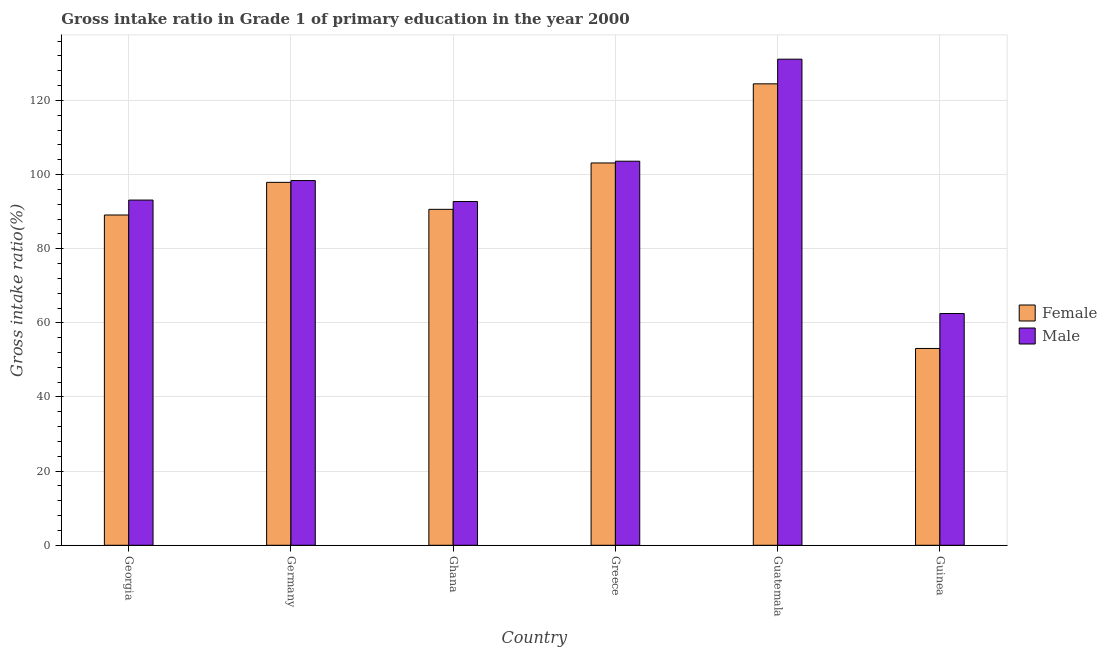How many different coloured bars are there?
Keep it short and to the point. 2. How many groups of bars are there?
Your answer should be very brief. 6. Are the number of bars on each tick of the X-axis equal?
Offer a terse response. Yes. How many bars are there on the 6th tick from the right?
Your answer should be compact. 2. What is the label of the 6th group of bars from the left?
Make the answer very short. Guinea. What is the gross intake ratio(male) in Greece?
Provide a succinct answer. 103.6. Across all countries, what is the maximum gross intake ratio(male)?
Offer a terse response. 131.12. Across all countries, what is the minimum gross intake ratio(male)?
Provide a succinct answer. 62.51. In which country was the gross intake ratio(male) maximum?
Provide a succinct answer. Guatemala. In which country was the gross intake ratio(male) minimum?
Give a very brief answer. Guinea. What is the total gross intake ratio(male) in the graph?
Offer a very short reply. 581.45. What is the difference between the gross intake ratio(female) in Georgia and that in Germany?
Your answer should be compact. -8.81. What is the difference between the gross intake ratio(female) in Ghana and the gross intake ratio(male) in Guatemala?
Offer a terse response. -40.5. What is the average gross intake ratio(female) per country?
Your answer should be compact. 93.05. What is the difference between the gross intake ratio(male) and gross intake ratio(female) in Guinea?
Ensure brevity in your answer.  9.42. What is the ratio of the gross intake ratio(male) in Guatemala to that in Guinea?
Provide a short and direct response. 2.1. Is the gross intake ratio(male) in Georgia less than that in Germany?
Give a very brief answer. Yes. What is the difference between the highest and the second highest gross intake ratio(female)?
Your answer should be compact. 21.34. What is the difference between the highest and the lowest gross intake ratio(male)?
Provide a succinct answer. 68.61. Are all the bars in the graph horizontal?
Offer a terse response. No. How many countries are there in the graph?
Ensure brevity in your answer.  6. Does the graph contain grids?
Ensure brevity in your answer.  Yes. How many legend labels are there?
Keep it short and to the point. 2. How are the legend labels stacked?
Make the answer very short. Vertical. What is the title of the graph?
Provide a short and direct response. Gross intake ratio in Grade 1 of primary education in the year 2000. What is the label or title of the X-axis?
Your answer should be very brief. Country. What is the label or title of the Y-axis?
Offer a very short reply. Gross intake ratio(%). What is the Gross intake ratio(%) in Female in Georgia?
Your response must be concise. 89.09. What is the Gross intake ratio(%) of Male in Georgia?
Give a very brief answer. 93.12. What is the Gross intake ratio(%) of Female in Germany?
Provide a succinct answer. 97.9. What is the Gross intake ratio(%) in Male in Germany?
Ensure brevity in your answer.  98.38. What is the Gross intake ratio(%) in Female in Ghana?
Offer a terse response. 90.62. What is the Gross intake ratio(%) of Male in Ghana?
Keep it short and to the point. 92.73. What is the Gross intake ratio(%) in Female in Greece?
Give a very brief answer. 103.13. What is the Gross intake ratio(%) in Male in Greece?
Your response must be concise. 103.6. What is the Gross intake ratio(%) in Female in Guatemala?
Offer a very short reply. 124.47. What is the Gross intake ratio(%) in Male in Guatemala?
Give a very brief answer. 131.12. What is the Gross intake ratio(%) in Female in Guinea?
Provide a short and direct response. 53.09. What is the Gross intake ratio(%) in Male in Guinea?
Offer a very short reply. 62.51. Across all countries, what is the maximum Gross intake ratio(%) in Female?
Offer a terse response. 124.47. Across all countries, what is the maximum Gross intake ratio(%) in Male?
Your response must be concise. 131.12. Across all countries, what is the minimum Gross intake ratio(%) in Female?
Make the answer very short. 53.09. Across all countries, what is the minimum Gross intake ratio(%) of Male?
Provide a succinct answer. 62.51. What is the total Gross intake ratio(%) of Female in the graph?
Offer a terse response. 558.29. What is the total Gross intake ratio(%) in Male in the graph?
Give a very brief answer. 581.45. What is the difference between the Gross intake ratio(%) of Female in Georgia and that in Germany?
Provide a succinct answer. -8.81. What is the difference between the Gross intake ratio(%) in Male in Georgia and that in Germany?
Offer a terse response. -5.26. What is the difference between the Gross intake ratio(%) of Female in Georgia and that in Ghana?
Your response must be concise. -1.53. What is the difference between the Gross intake ratio(%) of Male in Georgia and that in Ghana?
Ensure brevity in your answer.  0.39. What is the difference between the Gross intake ratio(%) in Female in Georgia and that in Greece?
Your response must be concise. -14.04. What is the difference between the Gross intake ratio(%) of Male in Georgia and that in Greece?
Provide a succinct answer. -10.48. What is the difference between the Gross intake ratio(%) of Female in Georgia and that in Guatemala?
Provide a succinct answer. -35.38. What is the difference between the Gross intake ratio(%) of Male in Georgia and that in Guatemala?
Provide a succinct answer. -38.01. What is the difference between the Gross intake ratio(%) of Female in Georgia and that in Guinea?
Provide a short and direct response. 36. What is the difference between the Gross intake ratio(%) in Male in Georgia and that in Guinea?
Offer a very short reply. 30.6. What is the difference between the Gross intake ratio(%) in Female in Germany and that in Ghana?
Offer a terse response. 7.28. What is the difference between the Gross intake ratio(%) of Male in Germany and that in Ghana?
Make the answer very short. 5.65. What is the difference between the Gross intake ratio(%) of Female in Germany and that in Greece?
Ensure brevity in your answer.  -5.23. What is the difference between the Gross intake ratio(%) in Male in Germany and that in Greece?
Offer a terse response. -5.22. What is the difference between the Gross intake ratio(%) in Female in Germany and that in Guatemala?
Provide a short and direct response. -26.57. What is the difference between the Gross intake ratio(%) in Male in Germany and that in Guatemala?
Offer a very short reply. -32.74. What is the difference between the Gross intake ratio(%) in Female in Germany and that in Guinea?
Keep it short and to the point. 44.81. What is the difference between the Gross intake ratio(%) in Male in Germany and that in Guinea?
Provide a short and direct response. 35.87. What is the difference between the Gross intake ratio(%) in Female in Ghana and that in Greece?
Give a very brief answer. -12.51. What is the difference between the Gross intake ratio(%) of Male in Ghana and that in Greece?
Provide a short and direct response. -10.87. What is the difference between the Gross intake ratio(%) of Female in Ghana and that in Guatemala?
Give a very brief answer. -33.85. What is the difference between the Gross intake ratio(%) of Male in Ghana and that in Guatemala?
Offer a terse response. -38.4. What is the difference between the Gross intake ratio(%) of Female in Ghana and that in Guinea?
Your answer should be compact. 37.53. What is the difference between the Gross intake ratio(%) in Male in Ghana and that in Guinea?
Ensure brevity in your answer.  30.21. What is the difference between the Gross intake ratio(%) of Female in Greece and that in Guatemala?
Your answer should be very brief. -21.34. What is the difference between the Gross intake ratio(%) of Male in Greece and that in Guatemala?
Give a very brief answer. -27.52. What is the difference between the Gross intake ratio(%) of Female in Greece and that in Guinea?
Provide a short and direct response. 50.04. What is the difference between the Gross intake ratio(%) in Male in Greece and that in Guinea?
Offer a terse response. 41.09. What is the difference between the Gross intake ratio(%) of Female in Guatemala and that in Guinea?
Provide a short and direct response. 71.38. What is the difference between the Gross intake ratio(%) in Male in Guatemala and that in Guinea?
Ensure brevity in your answer.  68.61. What is the difference between the Gross intake ratio(%) in Female in Georgia and the Gross intake ratio(%) in Male in Germany?
Offer a terse response. -9.29. What is the difference between the Gross intake ratio(%) of Female in Georgia and the Gross intake ratio(%) of Male in Ghana?
Ensure brevity in your answer.  -3.64. What is the difference between the Gross intake ratio(%) of Female in Georgia and the Gross intake ratio(%) of Male in Greece?
Provide a succinct answer. -14.51. What is the difference between the Gross intake ratio(%) in Female in Georgia and the Gross intake ratio(%) in Male in Guatemala?
Provide a short and direct response. -42.03. What is the difference between the Gross intake ratio(%) of Female in Georgia and the Gross intake ratio(%) of Male in Guinea?
Give a very brief answer. 26.58. What is the difference between the Gross intake ratio(%) in Female in Germany and the Gross intake ratio(%) in Male in Ghana?
Your answer should be very brief. 5.17. What is the difference between the Gross intake ratio(%) in Female in Germany and the Gross intake ratio(%) in Male in Greece?
Your answer should be compact. -5.7. What is the difference between the Gross intake ratio(%) of Female in Germany and the Gross intake ratio(%) of Male in Guatemala?
Ensure brevity in your answer.  -33.22. What is the difference between the Gross intake ratio(%) of Female in Germany and the Gross intake ratio(%) of Male in Guinea?
Make the answer very short. 35.38. What is the difference between the Gross intake ratio(%) in Female in Ghana and the Gross intake ratio(%) in Male in Greece?
Your response must be concise. -12.98. What is the difference between the Gross intake ratio(%) of Female in Ghana and the Gross intake ratio(%) of Male in Guatemala?
Your answer should be very brief. -40.5. What is the difference between the Gross intake ratio(%) in Female in Ghana and the Gross intake ratio(%) in Male in Guinea?
Make the answer very short. 28.1. What is the difference between the Gross intake ratio(%) of Female in Greece and the Gross intake ratio(%) of Male in Guatemala?
Offer a very short reply. -27.99. What is the difference between the Gross intake ratio(%) of Female in Greece and the Gross intake ratio(%) of Male in Guinea?
Your answer should be compact. 40.62. What is the difference between the Gross intake ratio(%) in Female in Guatemala and the Gross intake ratio(%) in Male in Guinea?
Offer a very short reply. 61.96. What is the average Gross intake ratio(%) of Female per country?
Provide a succinct answer. 93.05. What is the average Gross intake ratio(%) in Male per country?
Ensure brevity in your answer.  96.91. What is the difference between the Gross intake ratio(%) of Female and Gross intake ratio(%) of Male in Georgia?
Make the answer very short. -4.03. What is the difference between the Gross intake ratio(%) in Female and Gross intake ratio(%) in Male in Germany?
Ensure brevity in your answer.  -0.48. What is the difference between the Gross intake ratio(%) of Female and Gross intake ratio(%) of Male in Ghana?
Ensure brevity in your answer.  -2.11. What is the difference between the Gross intake ratio(%) in Female and Gross intake ratio(%) in Male in Greece?
Your response must be concise. -0.47. What is the difference between the Gross intake ratio(%) in Female and Gross intake ratio(%) in Male in Guatemala?
Provide a succinct answer. -6.65. What is the difference between the Gross intake ratio(%) in Female and Gross intake ratio(%) in Male in Guinea?
Your answer should be compact. -9.42. What is the ratio of the Gross intake ratio(%) of Female in Georgia to that in Germany?
Make the answer very short. 0.91. What is the ratio of the Gross intake ratio(%) in Male in Georgia to that in Germany?
Provide a succinct answer. 0.95. What is the ratio of the Gross intake ratio(%) of Female in Georgia to that in Ghana?
Your answer should be compact. 0.98. What is the ratio of the Gross intake ratio(%) in Female in Georgia to that in Greece?
Offer a terse response. 0.86. What is the ratio of the Gross intake ratio(%) of Male in Georgia to that in Greece?
Your answer should be very brief. 0.9. What is the ratio of the Gross intake ratio(%) in Female in Georgia to that in Guatemala?
Give a very brief answer. 0.72. What is the ratio of the Gross intake ratio(%) in Male in Georgia to that in Guatemala?
Keep it short and to the point. 0.71. What is the ratio of the Gross intake ratio(%) of Female in Georgia to that in Guinea?
Offer a very short reply. 1.68. What is the ratio of the Gross intake ratio(%) of Male in Georgia to that in Guinea?
Your answer should be very brief. 1.49. What is the ratio of the Gross intake ratio(%) of Female in Germany to that in Ghana?
Provide a succinct answer. 1.08. What is the ratio of the Gross intake ratio(%) in Male in Germany to that in Ghana?
Provide a short and direct response. 1.06. What is the ratio of the Gross intake ratio(%) in Female in Germany to that in Greece?
Your answer should be very brief. 0.95. What is the ratio of the Gross intake ratio(%) of Male in Germany to that in Greece?
Your response must be concise. 0.95. What is the ratio of the Gross intake ratio(%) of Female in Germany to that in Guatemala?
Your response must be concise. 0.79. What is the ratio of the Gross intake ratio(%) of Male in Germany to that in Guatemala?
Provide a succinct answer. 0.75. What is the ratio of the Gross intake ratio(%) of Female in Germany to that in Guinea?
Your response must be concise. 1.84. What is the ratio of the Gross intake ratio(%) in Male in Germany to that in Guinea?
Your answer should be very brief. 1.57. What is the ratio of the Gross intake ratio(%) in Female in Ghana to that in Greece?
Your response must be concise. 0.88. What is the ratio of the Gross intake ratio(%) in Male in Ghana to that in Greece?
Offer a very short reply. 0.9. What is the ratio of the Gross intake ratio(%) of Female in Ghana to that in Guatemala?
Keep it short and to the point. 0.73. What is the ratio of the Gross intake ratio(%) of Male in Ghana to that in Guatemala?
Offer a very short reply. 0.71. What is the ratio of the Gross intake ratio(%) of Female in Ghana to that in Guinea?
Ensure brevity in your answer.  1.71. What is the ratio of the Gross intake ratio(%) of Male in Ghana to that in Guinea?
Offer a very short reply. 1.48. What is the ratio of the Gross intake ratio(%) in Female in Greece to that in Guatemala?
Your answer should be compact. 0.83. What is the ratio of the Gross intake ratio(%) of Male in Greece to that in Guatemala?
Provide a short and direct response. 0.79. What is the ratio of the Gross intake ratio(%) of Female in Greece to that in Guinea?
Your response must be concise. 1.94. What is the ratio of the Gross intake ratio(%) in Male in Greece to that in Guinea?
Your response must be concise. 1.66. What is the ratio of the Gross intake ratio(%) in Female in Guatemala to that in Guinea?
Your response must be concise. 2.34. What is the ratio of the Gross intake ratio(%) in Male in Guatemala to that in Guinea?
Provide a short and direct response. 2.1. What is the difference between the highest and the second highest Gross intake ratio(%) of Female?
Ensure brevity in your answer.  21.34. What is the difference between the highest and the second highest Gross intake ratio(%) of Male?
Give a very brief answer. 27.52. What is the difference between the highest and the lowest Gross intake ratio(%) of Female?
Keep it short and to the point. 71.38. What is the difference between the highest and the lowest Gross intake ratio(%) of Male?
Your answer should be very brief. 68.61. 